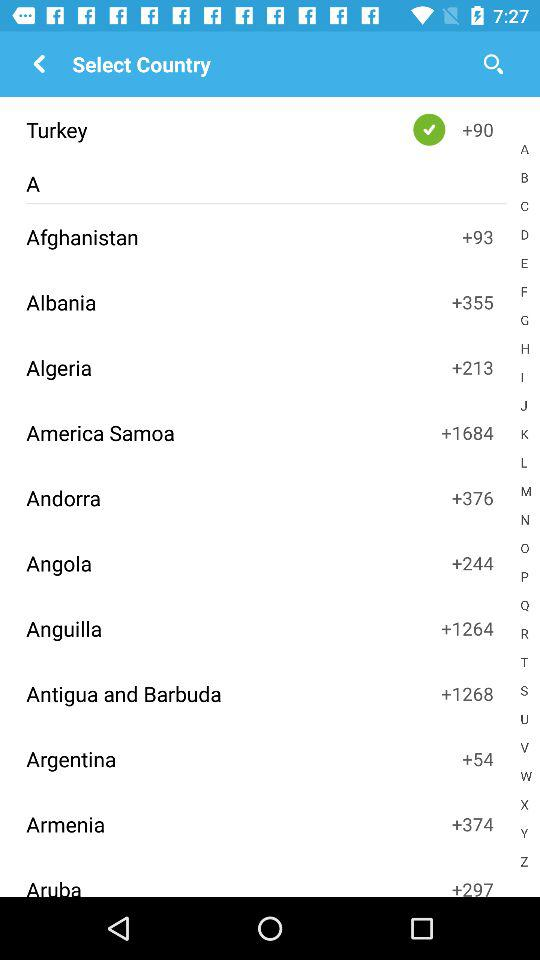What is the country code of Azerbaijan?
When the provided information is insufficient, respond with <no answer>. <no answer> 